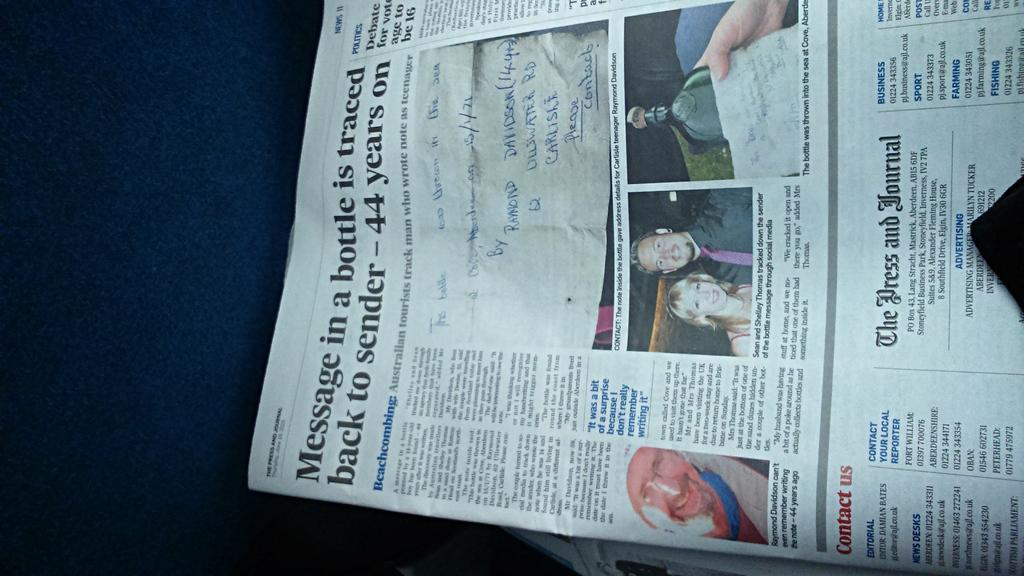What is the main object in the image? There is a newspaper in the image. What type of content can be found in the newspaper? The newspaper contains text and images of persons. What type of sheet is used to cover the ground in the image? There is no sheet or ground present in the image; it only features a newspaper with text and images of persons. 